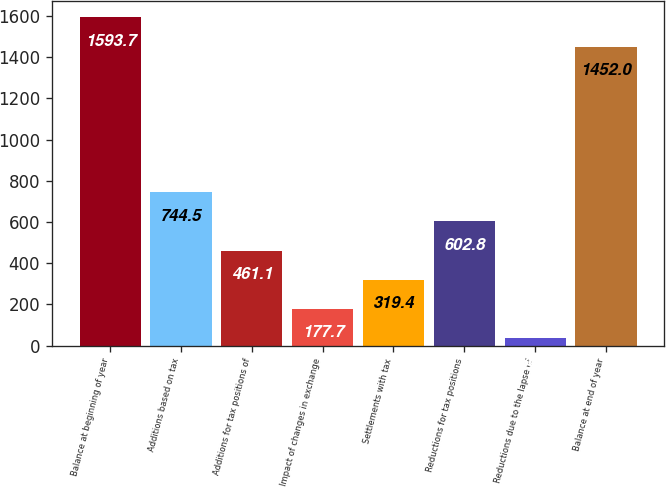Convert chart to OTSL. <chart><loc_0><loc_0><loc_500><loc_500><bar_chart><fcel>Balance at beginning of year<fcel>Additions based on tax<fcel>Additions for tax positions of<fcel>Impact of changes in exchange<fcel>Settlements with tax<fcel>Reductions for tax positions<fcel>Reductions due to the lapse of<fcel>Balance at end of year<nl><fcel>1593.7<fcel>744.5<fcel>461.1<fcel>177.7<fcel>319.4<fcel>602.8<fcel>36<fcel>1452<nl></chart> 